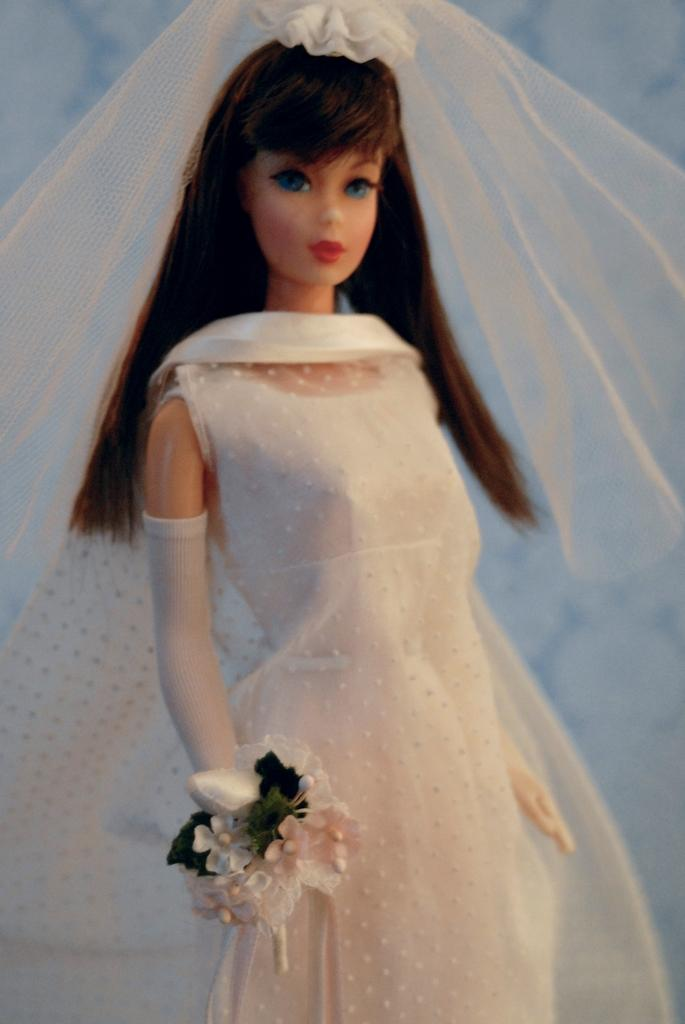What is the main subject of the picture? The main subject of the picture is a doll. What is the doll wearing? The doll is wearing a white dress. What is the doll holding? The doll is holding plastic flowers. What can be seen in the background of the picture? There is a wall visible in the background of the picture. What type of meat is the doll eating in the picture? There is no meat present in the image, and the doll is not eating anything. 